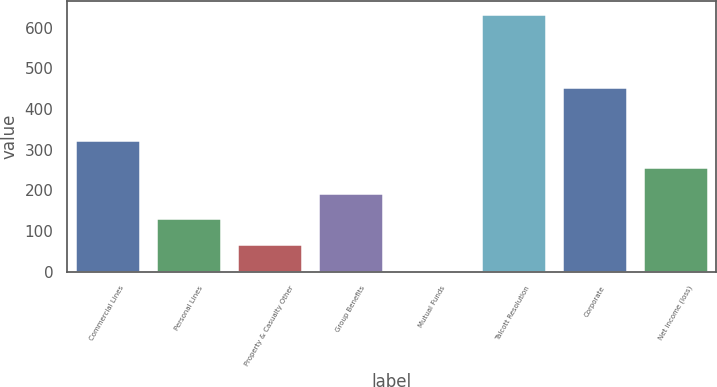<chart> <loc_0><loc_0><loc_500><loc_500><bar_chart><fcel>Commercial Lines<fcel>Personal Lines<fcel>Property & Casualty Other<fcel>Group Benefits<fcel>Mutual Funds<fcel>Talcott Resolution<fcel>Corporate<fcel>Net income (loss)<nl><fcel>323<fcel>131<fcel>68<fcel>194<fcel>5<fcel>635<fcel>454<fcel>257<nl></chart> 